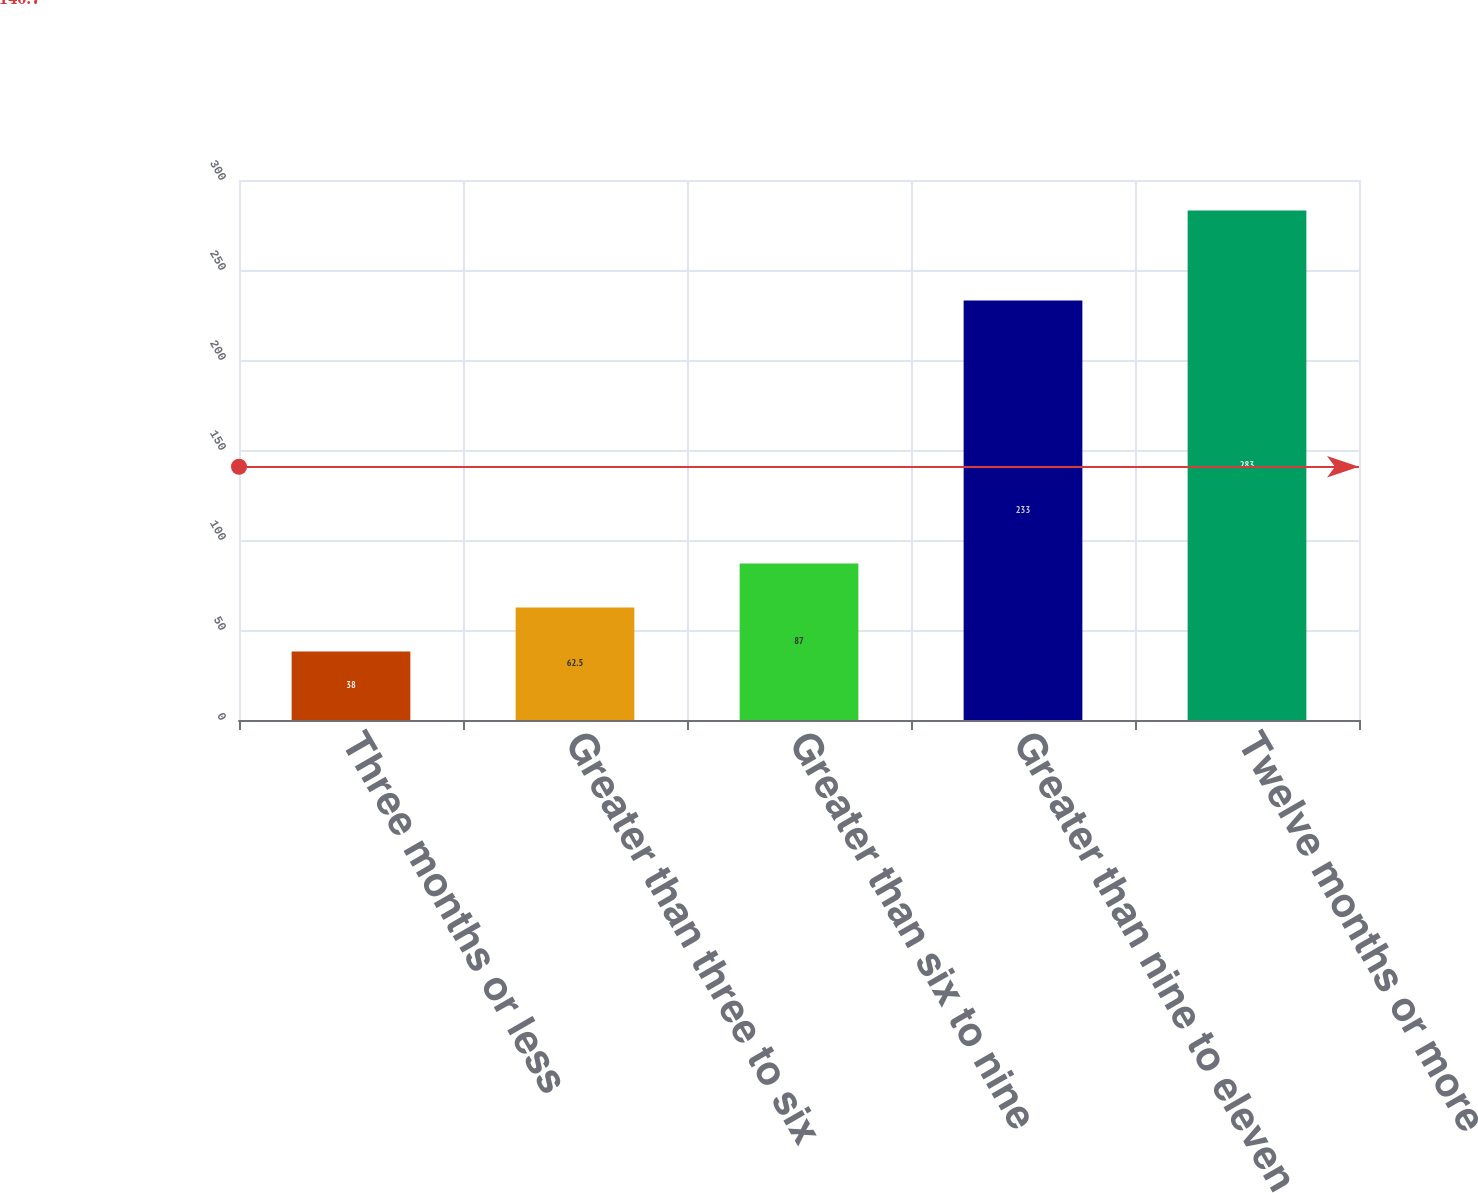Convert chart to OTSL. <chart><loc_0><loc_0><loc_500><loc_500><bar_chart><fcel>Three months or less<fcel>Greater than three to six<fcel>Greater than six to nine<fcel>Greater than nine to eleven<fcel>Twelve months or more<nl><fcel>38<fcel>62.5<fcel>87<fcel>233<fcel>283<nl></chart> 